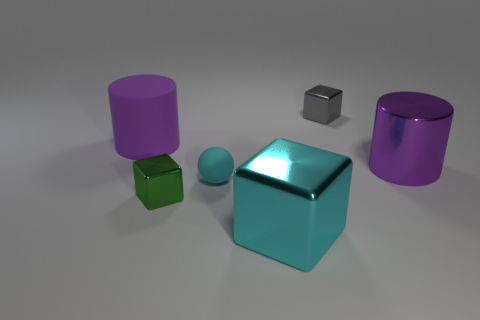Subtract all brown blocks. Subtract all cyan cylinders. How many blocks are left? 3 Add 1 red metallic objects. How many objects exist? 7 Subtract all spheres. How many objects are left? 5 Add 3 yellow metal blocks. How many yellow metal blocks exist? 3 Subtract 0 purple cubes. How many objects are left? 6 Subtract all green rubber blocks. Subtract all small matte balls. How many objects are left? 5 Add 5 big rubber things. How many big rubber things are left? 6 